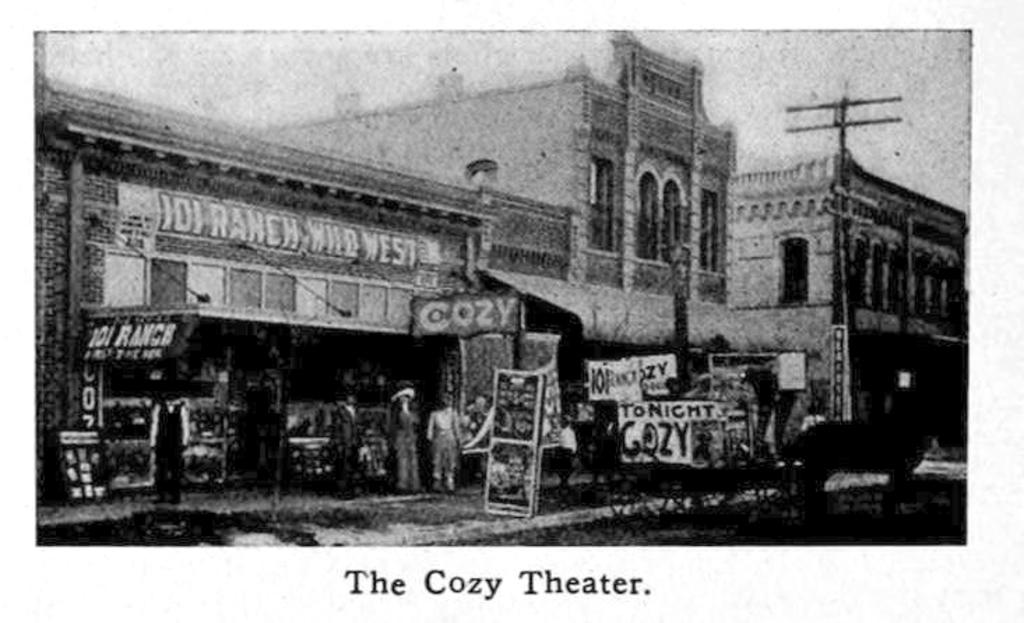What is the color scheme of the image? The image is black and white. What type of structures can be seen in the image? There are multiple buildings in the image. Are there any advertisements or signs visible in the image? Yes, there are hoardings in the image. What is happening on the road in the image? There are people standing on the road in the image. Can you tell me how many ears are visible on the people standing on the road in the image? There is no way to determine the number of ears visible on the people standing on the road in the image, as the image is black and white and does not provide enough detail to count individual body parts. 